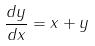<formula> <loc_0><loc_0><loc_500><loc_500>\frac { d y } { d x } = x + y</formula> 